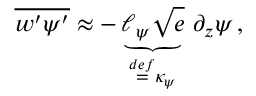Convert formula to latex. <formula><loc_0><loc_0><loc_500><loc_500>\overline { { w ^ { \prime } \psi ^ { \prime } } } \approx - \underbrace { \ell _ { \psi } \sqrt { e } } _ { { \stackrel { \ r { d e f } } { = } } \kappa _ { \psi } } \, \partial _ { z } \psi \, ,</formula> 